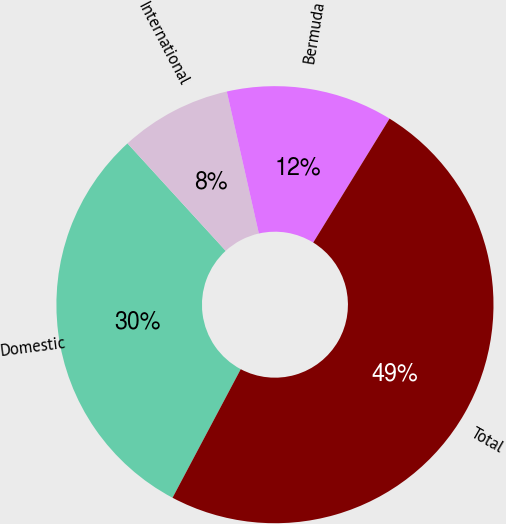Convert chart. <chart><loc_0><loc_0><loc_500><loc_500><pie_chart><fcel>Domestic<fcel>International<fcel>Bermuda<fcel>Total<nl><fcel>30.45%<fcel>8.25%<fcel>12.32%<fcel>48.98%<nl></chart> 